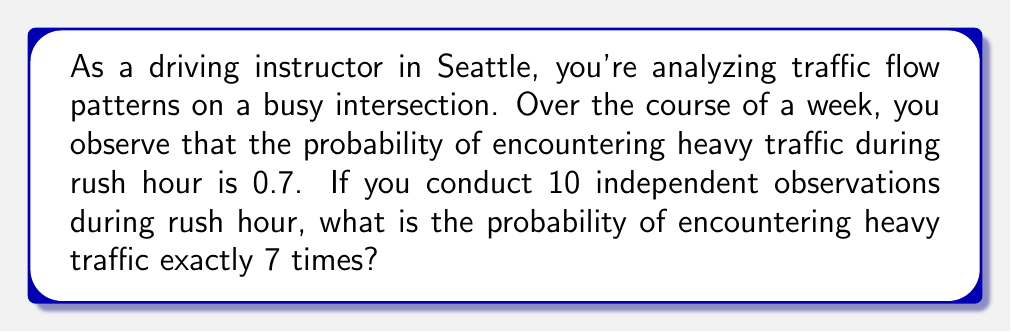Show me your answer to this math problem. To solve this problem, we'll use the Binomial probability distribution, as we have a fixed number of independent trials with two possible outcomes (heavy traffic or not) and a constant probability of success.

1) Let's define our variables:
   $n = 10$ (number of observations)
   $k = 7$ (number of successes we're interested in)
   $p = 0.7$ (probability of heavy traffic)
   $q = 1 - p = 0.3$ (probability of no heavy traffic)

2) The Binomial probability formula is:

   $$P(X = k) = \binom{n}{k} p^k q^{n-k}$$

3) Calculate the binomial coefficient:
   $$\binom{n}{k} = \binom{10}{7} = \frac{10!}{7!(10-7)!} = \frac{10!}{7!3!} = 120$$

4) Now, let's substitute all values into the formula:

   $$P(X = 7) = 120 \cdot (0.7)^7 \cdot (0.3)^{10-7}$$
   $$= 120 \cdot (0.7)^7 \cdot (0.3)^3$$

5) Calculate the result:
   $$= 120 \cdot 0.0823543 \cdot 0.027 = 0.2669$$

6) Round to four decimal places:
   $$= 0.2669$$

Therefore, the probability of encountering heavy traffic exactly 7 times out of 10 observations is approximately 0.2669 or 26.69%.
Answer: 0.2669 